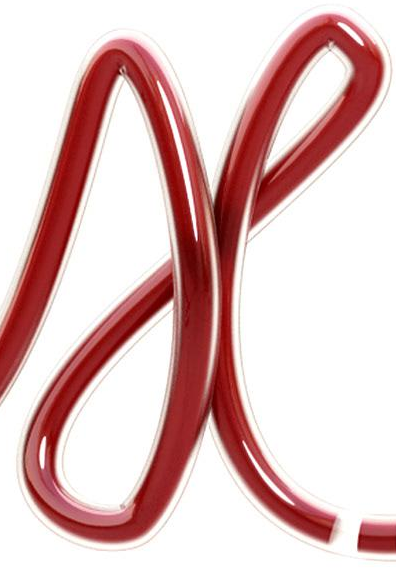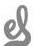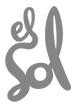Read the text from these images in sequence, separated by a semicolon. X; el; Sol 